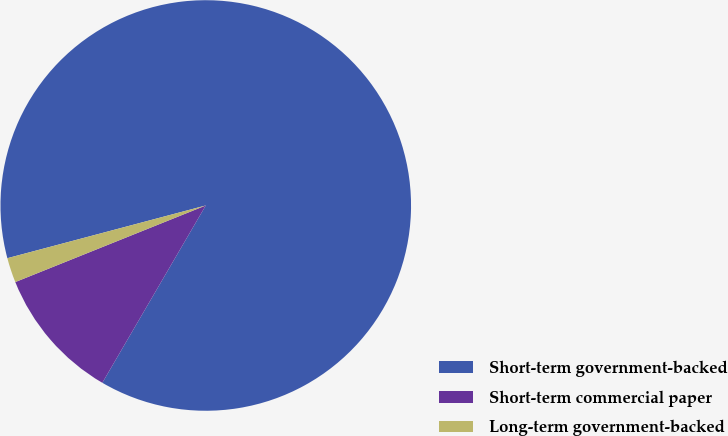<chart> <loc_0><loc_0><loc_500><loc_500><pie_chart><fcel>Short-term government-backed<fcel>Short-term commercial paper<fcel>Long-term government-backed<nl><fcel>87.54%<fcel>10.51%<fcel>1.95%<nl></chart> 